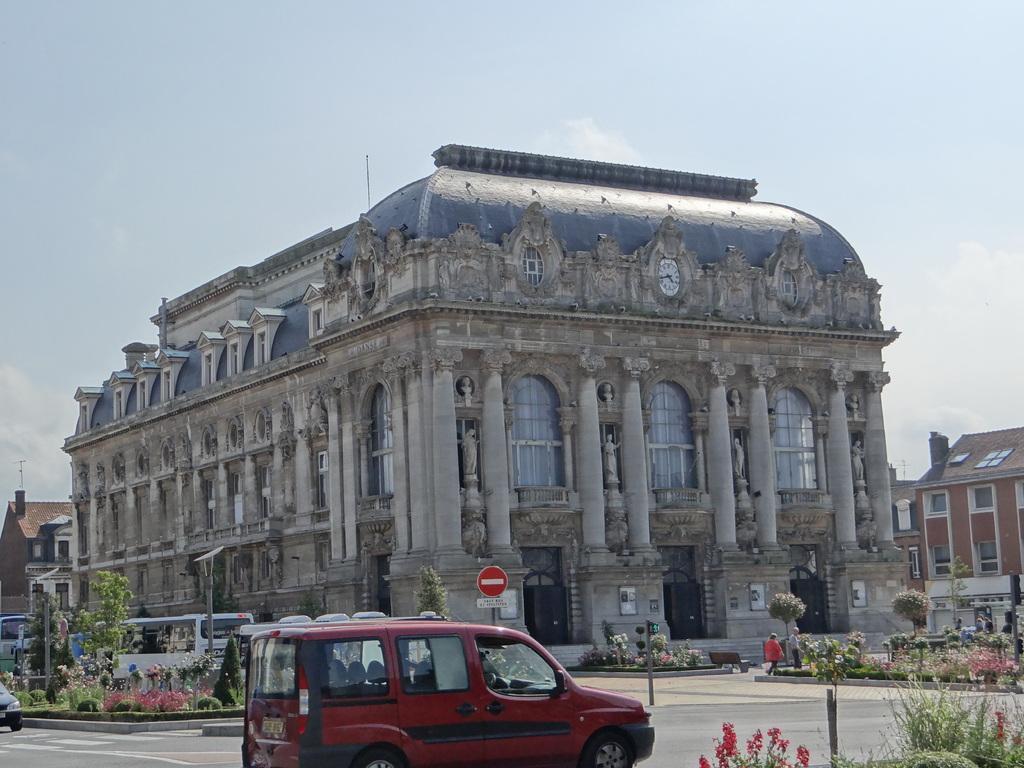Could you give a brief overview of what you see in this image? This picture might be taken from outside of the building. In this image, in the middle, we can see a vehicle which is moving on the road. On the right side, we can see some plants with flowers, group of people, trees, buildings. On the left side, we can see some vehicles which are moving on the road, trees, plants with flowers, pole, buildings. In the background, we can see hoardings, building, plant, flowers. At the top, we can see a sky, at the bottom, we can see a road. 